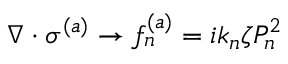Convert formula to latex. <formula><loc_0><loc_0><loc_500><loc_500>\nabla \cdot \sigma ^ { ( a ) } \rightarrow f _ { n } ^ { ( a ) } = i k _ { n } \zeta P _ { n } ^ { 2 }</formula> 